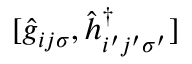<formula> <loc_0><loc_0><loc_500><loc_500>[ \hat { g } _ { i j \sigma } , \hat { h } _ { i ^ { \prime } j ^ { \prime } \sigma ^ { \prime } } ^ { \dagger } ]</formula> 